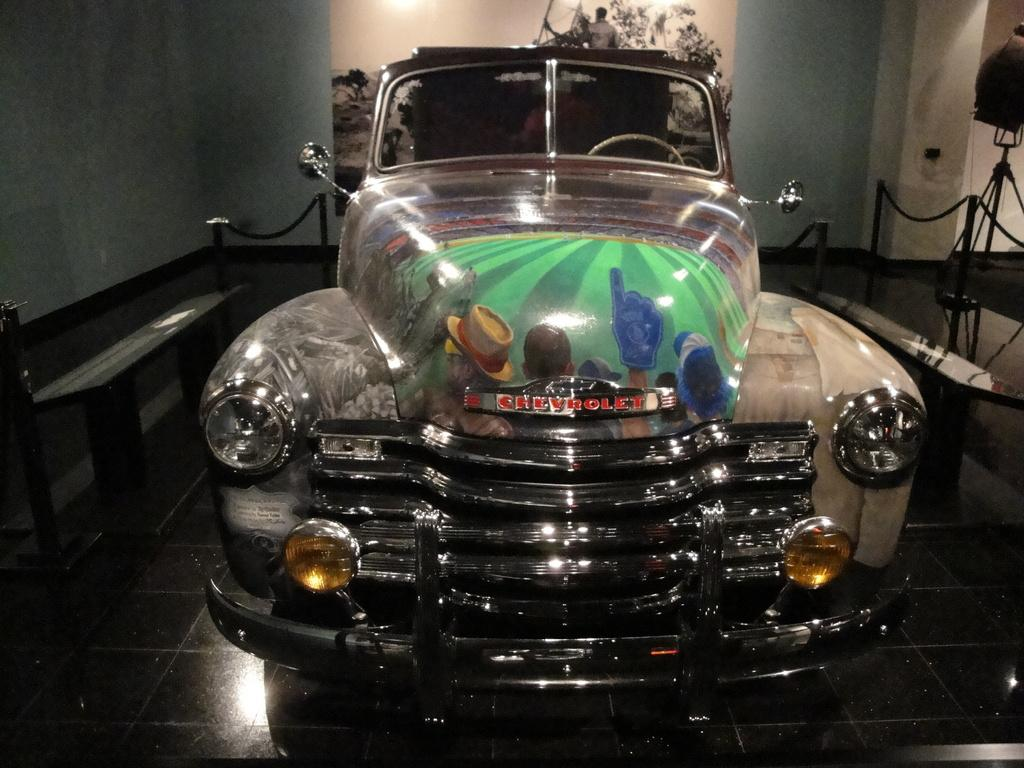What is on the road in the image? There is a car on the road in the image. What can be seen in the background of the image? There is a fence, a table, and a frame on the wall visible in the background. Where is the object on a stand located in the image? The object on a stand is on the floor on the right side of the image. What type of bait is the squirrel using to catch the car in the image? There is no squirrel present in the image, and therefore no bait or attempt to catch the car can be observed. 